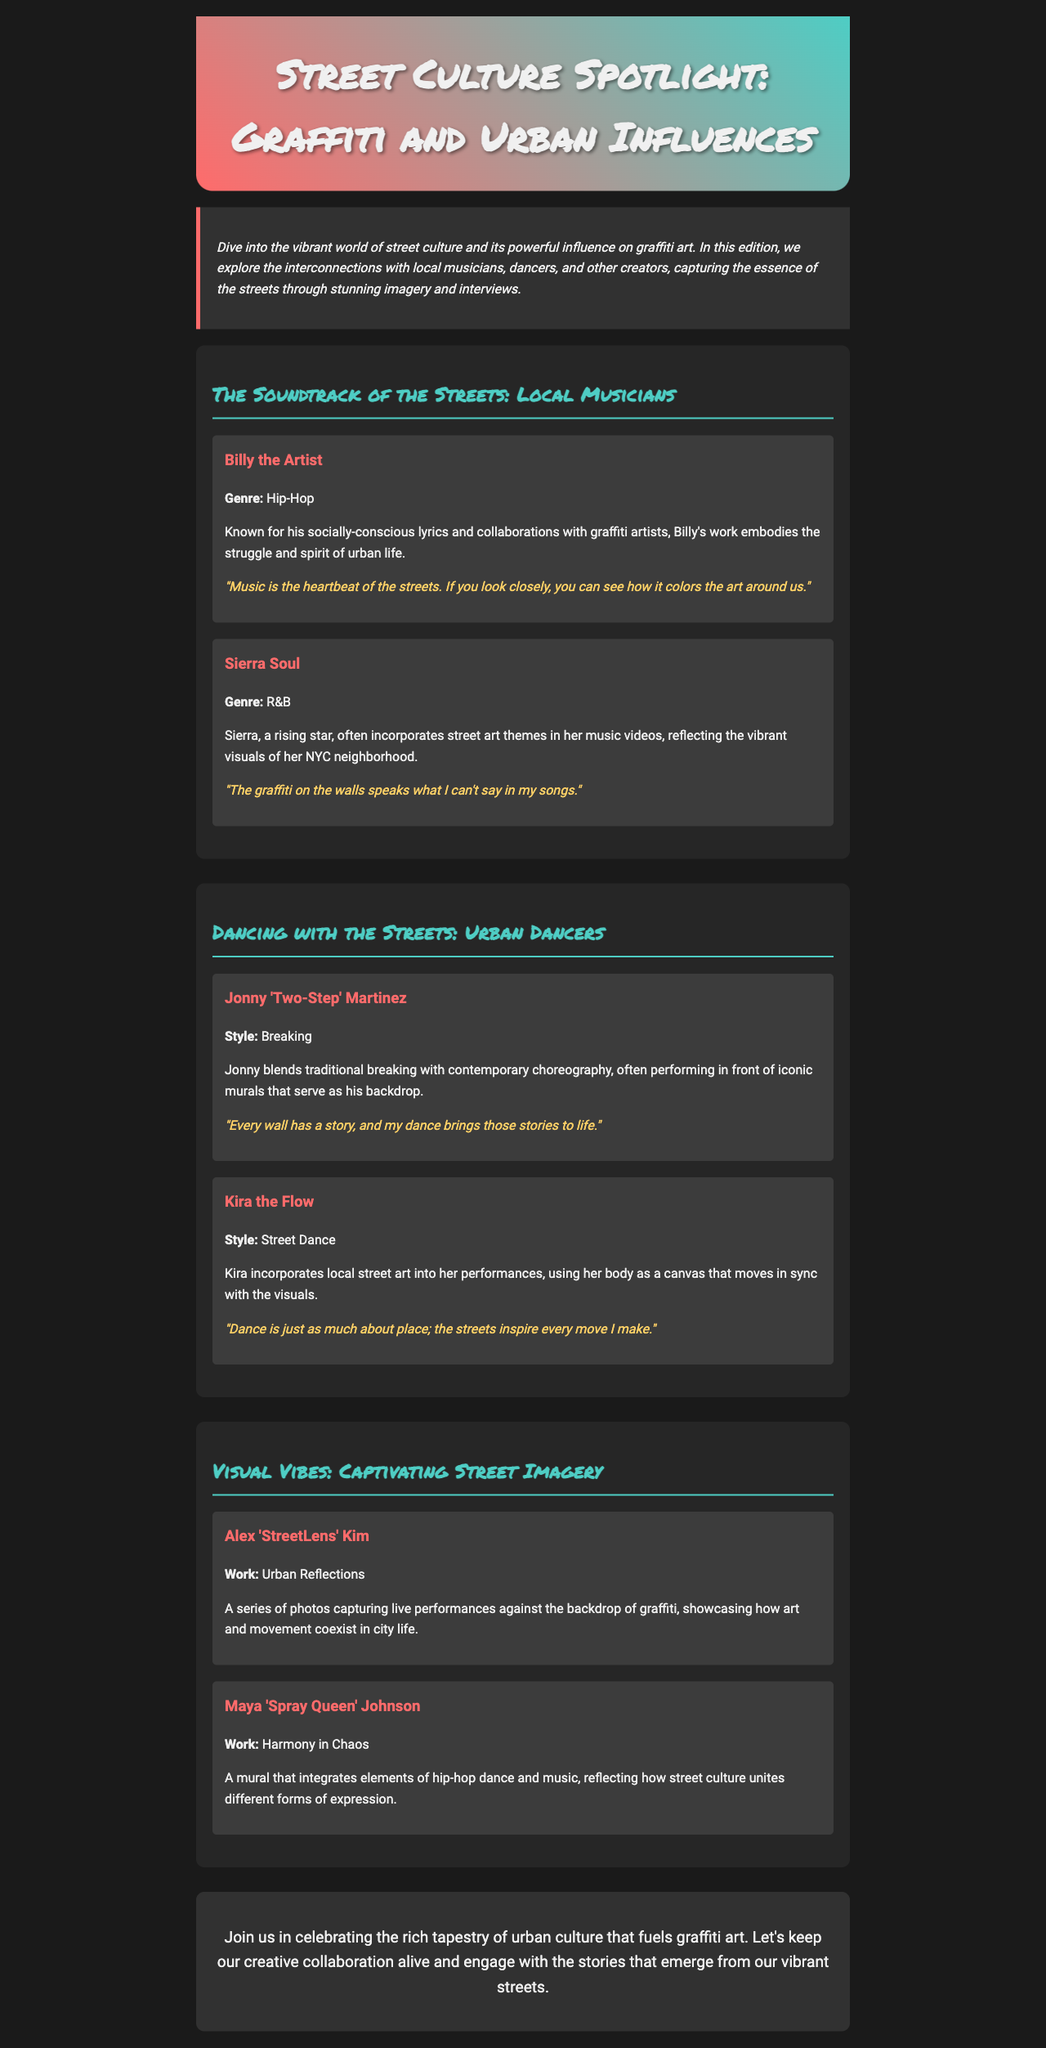What is the title of the newsletter? The title of the newsletter is prominently displayed in the header section, introducing the main theme.
Answer: Street Culture Spotlight: Graffiti and Urban Influences Who is featured as the musician known for hip-hop? This information is specified in the section highlighting local musicians, identifying each artist's genre.
Answer: Billy the Artist What style does Jonny 'Two-Step' Martinez perform? The style is indicated under the dancer's profile, providing a quick reference for their dance genre.
Answer: Breaking How many local musicians are interviewed in the newsletter? The document lists two local musicians, making it easy to determine the count based on this section.
Answer: 2 What work is associated with Maya 'Spray Queen' Johnson? This refers to the specific artistic work mentioned in the section about visual vibes, showcasing her contributions to street culture.
Answer: Harmony in Chaos Which dancer incorporates local street art into performances? The dancer's description mentions their unique approach in relation to the street art theme, making it clear who this refers to.
Answer: Kira the Flow What is the main purpose of the newsletter? The purpose is seen in the introductory paragraph, which summarizes the newsletter's focus and intent regarding urban culture and graffiti.
Answer: To celebrate urban culture What genre of music does Sierra Soul represent? This detail is conveyed in her artist section, providing insight into her musical style.
Answer: R&B What color is the border of the intro section? The color is specified in the style rules, contributing to the document's visual design.
Answer: #ff6b6b 